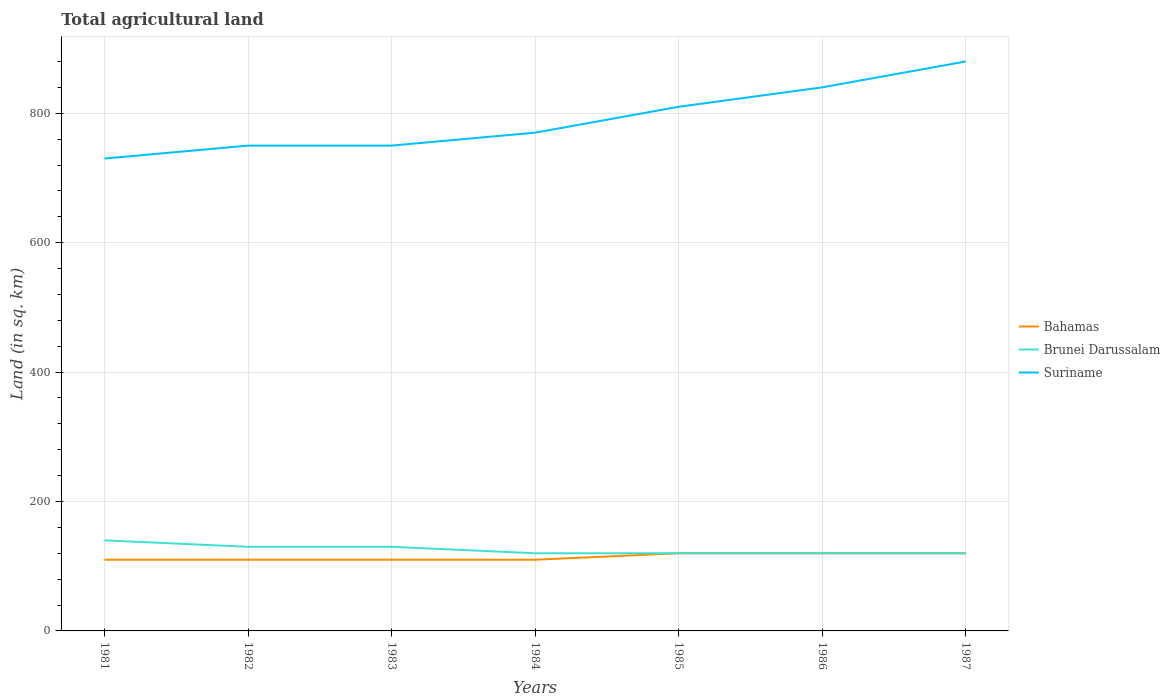Is the number of lines equal to the number of legend labels?
Ensure brevity in your answer.  Yes. Across all years, what is the maximum total agricultural land in Bahamas?
Your answer should be very brief. 110. What is the total total agricultural land in Bahamas in the graph?
Offer a very short reply. -10. What is the difference between the highest and the second highest total agricultural land in Brunei Darussalam?
Provide a succinct answer. 20. How many lines are there?
Your answer should be compact. 3. How many years are there in the graph?
Your answer should be very brief. 7. Are the values on the major ticks of Y-axis written in scientific E-notation?
Your answer should be compact. No. Does the graph contain any zero values?
Your response must be concise. No. Does the graph contain grids?
Your answer should be very brief. Yes. Where does the legend appear in the graph?
Provide a short and direct response. Center right. How many legend labels are there?
Keep it short and to the point. 3. How are the legend labels stacked?
Give a very brief answer. Vertical. What is the title of the graph?
Ensure brevity in your answer.  Total agricultural land. What is the label or title of the X-axis?
Offer a terse response. Years. What is the label or title of the Y-axis?
Offer a very short reply. Land (in sq. km). What is the Land (in sq. km) of Bahamas in 1981?
Keep it short and to the point. 110. What is the Land (in sq. km) in Brunei Darussalam in 1981?
Give a very brief answer. 140. What is the Land (in sq. km) in Suriname in 1981?
Keep it short and to the point. 730. What is the Land (in sq. km) of Bahamas in 1982?
Make the answer very short. 110. What is the Land (in sq. km) in Brunei Darussalam in 1982?
Make the answer very short. 130. What is the Land (in sq. km) of Suriname in 1982?
Your answer should be very brief. 750. What is the Land (in sq. km) of Bahamas in 1983?
Your answer should be very brief. 110. What is the Land (in sq. km) in Brunei Darussalam in 1983?
Offer a very short reply. 130. What is the Land (in sq. km) in Suriname in 1983?
Make the answer very short. 750. What is the Land (in sq. km) of Bahamas in 1984?
Your answer should be very brief. 110. What is the Land (in sq. km) of Brunei Darussalam in 1984?
Your response must be concise. 120. What is the Land (in sq. km) of Suriname in 1984?
Make the answer very short. 770. What is the Land (in sq. km) in Bahamas in 1985?
Offer a terse response. 120. What is the Land (in sq. km) in Brunei Darussalam in 1985?
Ensure brevity in your answer.  120. What is the Land (in sq. km) of Suriname in 1985?
Give a very brief answer. 810. What is the Land (in sq. km) of Bahamas in 1986?
Give a very brief answer. 120. What is the Land (in sq. km) of Brunei Darussalam in 1986?
Offer a very short reply. 120. What is the Land (in sq. km) of Suriname in 1986?
Make the answer very short. 840. What is the Land (in sq. km) in Bahamas in 1987?
Ensure brevity in your answer.  120. What is the Land (in sq. km) in Brunei Darussalam in 1987?
Your answer should be very brief. 120. What is the Land (in sq. km) in Suriname in 1987?
Your answer should be compact. 880. Across all years, what is the maximum Land (in sq. km) in Bahamas?
Offer a terse response. 120. Across all years, what is the maximum Land (in sq. km) of Brunei Darussalam?
Make the answer very short. 140. Across all years, what is the maximum Land (in sq. km) of Suriname?
Give a very brief answer. 880. Across all years, what is the minimum Land (in sq. km) in Bahamas?
Your response must be concise. 110. Across all years, what is the minimum Land (in sq. km) of Brunei Darussalam?
Your answer should be compact. 120. Across all years, what is the minimum Land (in sq. km) of Suriname?
Offer a very short reply. 730. What is the total Land (in sq. km) of Bahamas in the graph?
Keep it short and to the point. 800. What is the total Land (in sq. km) of Brunei Darussalam in the graph?
Ensure brevity in your answer.  880. What is the total Land (in sq. km) of Suriname in the graph?
Make the answer very short. 5530. What is the difference between the Land (in sq. km) in Bahamas in 1981 and that in 1982?
Give a very brief answer. 0. What is the difference between the Land (in sq. km) of Brunei Darussalam in 1981 and that in 1982?
Offer a very short reply. 10. What is the difference between the Land (in sq. km) of Bahamas in 1981 and that in 1983?
Offer a terse response. 0. What is the difference between the Land (in sq. km) of Brunei Darussalam in 1981 and that in 1983?
Your answer should be compact. 10. What is the difference between the Land (in sq. km) of Suriname in 1981 and that in 1983?
Your answer should be compact. -20. What is the difference between the Land (in sq. km) of Brunei Darussalam in 1981 and that in 1984?
Provide a succinct answer. 20. What is the difference between the Land (in sq. km) of Suriname in 1981 and that in 1984?
Provide a succinct answer. -40. What is the difference between the Land (in sq. km) in Bahamas in 1981 and that in 1985?
Make the answer very short. -10. What is the difference between the Land (in sq. km) of Suriname in 1981 and that in 1985?
Give a very brief answer. -80. What is the difference between the Land (in sq. km) in Bahamas in 1981 and that in 1986?
Provide a succinct answer. -10. What is the difference between the Land (in sq. km) of Brunei Darussalam in 1981 and that in 1986?
Your response must be concise. 20. What is the difference between the Land (in sq. km) in Suriname in 1981 and that in 1986?
Provide a short and direct response. -110. What is the difference between the Land (in sq. km) in Bahamas in 1981 and that in 1987?
Keep it short and to the point. -10. What is the difference between the Land (in sq. km) of Brunei Darussalam in 1981 and that in 1987?
Give a very brief answer. 20. What is the difference between the Land (in sq. km) in Suriname in 1981 and that in 1987?
Offer a terse response. -150. What is the difference between the Land (in sq. km) of Bahamas in 1982 and that in 1983?
Your answer should be very brief. 0. What is the difference between the Land (in sq. km) in Brunei Darussalam in 1982 and that in 1983?
Make the answer very short. 0. What is the difference between the Land (in sq. km) of Suriname in 1982 and that in 1983?
Your answer should be very brief. 0. What is the difference between the Land (in sq. km) of Suriname in 1982 and that in 1985?
Provide a succinct answer. -60. What is the difference between the Land (in sq. km) of Bahamas in 1982 and that in 1986?
Make the answer very short. -10. What is the difference between the Land (in sq. km) in Brunei Darussalam in 1982 and that in 1986?
Provide a short and direct response. 10. What is the difference between the Land (in sq. km) in Suriname in 1982 and that in 1986?
Give a very brief answer. -90. What is the difference between the Land (in sq. km) of Suriname in 1982 and that in 1987?
Provide a succinct answer. -130. What is the difference between the Land (in sq. km) of Suriname in 1983 and that in 1984?
Your answer should be compact. -20. What is the difference between the Land (in sq. km) of Bahamas in 1983 and that in 1985?
Keep it short and to the point. -10. What is the difference between the Land (in sq. km) of Suriname in 1983 and that in 1985?
Your response must be concise. -60. What is the difference between the Land (in sq. km) of Bahamas in 1983 and that in 1986?
Your response must be concise. -10. What is the difference between the Land (in sq. km) of Suriname in 1983 and that in 1986?
Offer a terse response. -90. What is the difference between the Land (in sq. km) in Bahamas in 1983 and that in 1987?
Your answer should be very brief. -10. What is the difference between the Land (in sq. km) in Brunei Darussalam in 1983 and that in 1987?
Ensure brevity in your answer.  10. What is the difference between the Land (in sq. km) in Suriname in 1983 and that in 1987?
Keep it short and to the point. -130. What is the difference between the Land (in sq. km) of Bahamas in 1984 and that in 1985?
Make the answer very short. -10. What is the difference between the Land (in sq. km) in Brunei Darussalam in 1984 and that in 1985?
Make the answer very short. 0. What is the difference between the Land (in sq. km) of Suriname in 1984 and that in 1985?
Keep it short and to the point. -40. What is the difference between the Land (in sq. km) of Brunei Darussalam in 1984 and that in 1986?
Keep it short and to the point. 0. What is the difference between the Land (in sq. km) in Suriname in 1984 and that in 1986?
Your response must be concise. -70. What is the difference between the Land (in sq. km) in Bahamas in 1984 and that in 1987?
Ensure brevity in your answer.  -10. What is the difference between the Land (in sq. km) in Suriname in 1984 and that in 1987?
Make the answer very short. -110. What is the difference between the Land (in sq. km) in Bahamas in 1985 and that in 1986?
Ensure brevity in your answer.  0. What is the difference between the Land (in sq. km) in Brunei Darussalam in 1985 and that in 1986?
Make the answer very short. 0. What is the difference between the Land (in sq. km) of Bahamas in 1985 and that in 1987?
Make the answer very short. 0. What is the difference between the Land (in sq. km) of Brunei Darussalam in 1985 and that in 1987?
Offer a very short reply. 0. What is the difference between the Land (in sq. km) of Suriname in 1985 and that in 1987?
Your response must be concise. -70. What is the difference between the Land (in sq. km) of Brunei Darussalam in 1986 and that in 1987?
Ensure brevity in your answer.  0. What is the difference between the Land (in sq. km) in Suriname in 1986 and that in 1987?
Provide a succinct answer. -40. What is the difference between the Land (in sq. km) of Bahamas in 1981 and the Land (in sq. km) of Suriname in 1982?
Your answer should be compact. -640. What is the difference between the Land (in sq. km) of Brunei Darussalam in 1981 and the Land (in sq. km) of Suriname in 1982?
Provide a short and direct response. -610. What is the difference between the Land (in sq. km) in Bahamas in 1981 and the Land (in sq. km) in Brunei Darussalam in 1983?
Keep it short and to the point. -20. What is the difference between the Land (in sq. km) in Bahamas in 1981 and the Land (in sq. km) in Suriname in 1983?
Your answer should be compact. -640. What is the difference between the Land (in sq. km) in Brunei Darussalam in 1981 and the Land (in sq. km) in Suriname in 1983?
Provide a short and direct response. -610. What is the difference between the Land (in sq. km) of Bahamas in 1981 and the Land (in sq. km) of Suriname in 1984?
Provide a succinct answer. -660. What is the difference between the Land (in sq. km) in Brunei Darussalam in 1981 and the Land (in sq. km) in Suriname in 1984?
Give a very brief answer. -630. What is the difference between the Land (in sq. km) in Bahamas in 1981 and the Land (in sq. km) in Suriname in 1985?
Offer a very short reply. -700. What is the difference between the Land (in sq. km) of Brunei Darussalam in 1981 and the Land (in sq. km) of Suriname in 1985?
Provide a short and direct response. -670. What is the difference between the Land (in sq. km) in Bahamas in 1981 and the Land (in sq. km) in Suriname in 1986?
Keep it short and to the point. -730. What is the difference between the Land (in sq. km) of Brunei Darussalam in 1981 and the Land (in sq. km) of Suriname in 1986?
Provide a short and direct response. -700. What is the difference between the Land (in sq. km) in Bahamas in 1981 and the Land (in sq. km) in Brunei Darussalam in 1987?
Provide a short and direct response. -10. What is the difference between the Land (in sq. km) of Bahamas in 1981 and the Land (in sq. km) of Suriname in 1987?
Offer a terse response. -770. What is the difference between the Land (in sq. km) in Brunei Darussalam in 1981 and the Land (in sq. km) in Suriname in 1987?
Give a very brief answer. -740. What is the difference between the Land (in sq. km) of Bahamas in 1982 and the Land (in sq. km) of Suriname in 1983?
Provide a short and direct response. -640. What is the difference between the Land (in sq. km) of Brunei Darussalam in 1982 and the Land (in sq. km) of Suriname in 1983?
Your response must be concise. -620. What is the difference between the Land (in sq. km) in Bahamas in 1982 and the Land (in sq. km) in Suriname in 1984?
Offer a very short reply. -660. What is the difference between the Land (in sq. km) in Brunei Darussalam in 1982 and the Land (in sq. km) in Suriname in 1984?
Ensure brevity in your answer.  -640. What is the difference between the Land (in sq. km) in Bahamas in 1982 and the Land (in sq. km) in Suriname in 1985?
Keep it short and to the point. -700. What is the difference between the Land (in sq. km) of Brunei Darussalam in 1982 and the Land (in sq. km) of Suriname in 1985?
Provide a short and direct response. -680. What is the difference between the Land (in sq. km) of Bahamas in 1982 and the Land (in sq. km) of Suriname in 1986?
Offer a terse response. -730. What is the difference between the Land (in sq. km) of Brunei Darussalam in 1982 and the Land (in sq. km) of Suriname in 1986?
Keep it short and to the point. -710. What is the difference between the Land (in sq. km) of Bahamas in 1982 and the Land (in sq. km) of Suriname in 1987?
Your answer should be compact. -770. What is the difference between the Land (in sq. km) in Brunei Darussalam in 1982 and the Land (in sq. km) in Suriname in 1987?
Make the answer very short. -750. What is the difference between the Land (in sq. km) of Bahamas in 1983 and the Land (in sq. km) of Suriname in 1984?
Keep it short and to the point. -660. What is the difference between the Land (in sq. km) in Brunei Darussalam in 1983 and the Land (in sq. km) in Suriname in 1984?
Ensure brevity in your answer.  -640. What is the difference between the Land (in sq. km) of Bahamas in 1983 and the Land (in sq. km) of Suriname in 1985?
Your answer should be compact. -700. What is the difference between the Land (in sq. km) in Brunei Darussalam in 1983 and the Land (in sq. km) in Suriname in 1985?
Provide a short and direct response. -680. What is the difference between the Land (in sq. km) in Bahamas in 1983 and the Land (in sq. km) in Brunei Darussalam in 1986?
Provide a short and direct response. -10. What is the difference between the Land (in sq. km) in Bahamas in 1983 and the Land (in sq. km) in Suriname in 1986?
Offer a very short reply. -730. What is the difference between the Land (in sq. km) of Brunei Darussalam in 1983 and the Land (in sq. km) of Suriname in 1986?
Provide a short and direct response. -710. What is the difference between the Land (in sq. km) of Bahamas in 1983 and the Land (in sq. km) of Brunei Darussalam in 1987?
Give a very brief answer. -10. What is the difference between the Land (in sq. km) in Bahamas in 1983 and the Land (in sq. km) in Suriname in 1987?
Keep it short and to the point. -770. What is the difference between the Land (in sq. km) of Brunei Darussalam in 1983 and the Land (in sq. km) of Suriname in 1987?
Provide a succinct answer. -750. What is the difference between the Land (in sq. km) of Bahamas in 1984 and the Land (in sq. km) of Suriname in 1985?
Provide a short and direct response. -700. What is the difference between the Land (in sq. km) of Brunei Darussalam in 1984 and the Land (in sq. km) of Suriname in 1985?
Keep it short and to the point. -690. What is the difference between the Land (in sq. km) of Bahamas in 1984 and the Land (in sq. km) of Brunei Darussalam in 1986?
Keep it short and to the point. -10. What is the difference between the Land (in sq. km) of Bahamas in 1984 and the Land (in sq. km) of Suriname in 1986?
Provide a short and direct response. -730. What is the difference between the Land (in sq. km) of Brunei Darussalam in 1984 and the Land (in sq. km) of Suriname in 1986?
Give a very brief answer. -720. What is the difference between the Land (in sq. km) in Bahamas in 1984 and the Land (in sq. km) in Brunei Darussalam in 1987?
Give a very brief answer. -10. What is the difference between the Land (in sq. km) of Bahamas in 1984 and the Land (in sq. km) of Suriname in 1987?
Your answer should be very brief. -770. What is the difference between the Land (in sq. km) of Brunei Darussalam in 1984 and the Land (in sq. km) of Suriname in 1987?
Offer a very short reply. -760. What is the difference between the Land (in sq. km) in Bahamas in 1985 and the Land (in sq. km) in Suriname in 1986?
Your answer should be compact. -720. What is the difference between the Land (in sq. km) of Brunei Darussalam in 1985 and the Land (in sq. km) of Suriname in 1986?
Make the answer very short. -720. What is the difference between the Land (in sq. km) in Bahamas in 1985 and the Land (in sq. km) in Suriname in 1987?
Your answer should be compact. -760. What is the difference between the Land (in sq. km) in Brunei Darussalam in 1985 and the Land (in sq. km) in Suriname in 1987?
Keep it short and to the point. -760. What is the difference between the Land (in sq. km) of Bahamas in 1986 and the Land (in sq. km) of Brunei Darussalam in 1987?
Offer a terse response. 0. What is the difference between the Land (in sq. km) in Bahamas in 1986 and the Land (in sq. km) in Suriname in 1987?
Provide a succinct answer. -760. What is the difference between the Land (in sq. km) in Brunei Darussalam in 1986 and the Land (in sq. km) in Suriname in 1987?
Your response must be concise. -760. What is the average Land (in sq. km) of Bahamas per year?
Give a very brief answer. 114.29. What is the average Land (in sq. km) of Brunei Darussalam per year?
Your answer should be very brief. 125.71. What is the average Land (in sq. km) of Suriname per year?
Give a very brief answer. 790. In the year 1981, what is the difference between the Land (in sq. km) in Bahamas and Land (in sq. km) in Suriname?
Your answer should be very brief. -620. In the year 1981, what is the difference between the Land (in sq. km) of Brunei Darussalam and Land (in sq. km) of Suriname?
Your response must be concise. -590. In the year 1982, what is the difference between the Land (in sq. km) of Bahamas and Land (in sq. km) of Brunei Darussalam?
Make the answer very short. -20. In the year 1982, what is the difference between the Land (in sq. km) of Bahamas and Land (in sq. km) of Suriname?
Keep it short and to the point. -640. In the year 1982, what is the difference between the Land (in sq. km) of Brunei Darussalam and Land (in sq. km) of Suriname?
Keep it short and to the point. -620. In the year 1983, what is the difference between the Land (in sq. km) of Bahamas and Land (in sq. km) of Suriname?
Ensure brevity in your answer.  -640. In the year 1983, what is the difference between the Land (in sq. km) of Brunei Darussalam and Land (in sq. km) of Suriname?
Make the answer very short. -620. In the year 1984, what is the difference between the Land (in sq. km) of Bahamas and Land (in sq. km) of Brunei Darussalam?
Provide a short and direct response. -10. In the year 1984, what is the difference between the Land (in sq. km) in Bahamas and Land (in sq. km) in Suriname?
Provide a succinct answer. -660. In the year 1984, what is the difference between the Land (in sq. km) in Brunei Darussalam and Land (in sq. km) in Suriname?
Your response must be concise. -650. In the year 1985, what is the difference between the Land (in sq. km) in Bahamas and Land (in sq. km) in Brunei Darussalam?
Offer a terse response. 0. In the year 1985, what is the difference between the Land (in sq. km) in Bahamas and Land (in sq. km) in Suriname?
Offer a terse response. -690. In the year 1985, what is the difference between the Land (in sq. km) of Brunei Darussalam and Land (in sq. km) of Suriname?
Provide a succinct answer. -690. In the year 1986, what is the difference between the Land (in sq. km) of Bahamas and Land (in sq. km) of Suriname?
Ensure brevity in your answer.  -720. In the year 1986, what is the difference between the Land (in sq. km) in Brunei Darussalam and Land (in sq. km) in Suriname?
Give a very brief answer. -720. In the year 1987, what is the difference between the Land (in sq. km) of Bahamas and Land (in sq. km) of Brunei Darussalam?
Ensure brevity in your answer.  0. In the year 1987, what is the difference between the Land (in sq. km) in Bahamas and Land (in sq. km) in Suriname?
Make the answer very short. -760. In the year 1987, what is the difference between the Land (in sq. km) of Brunei Darussalam and Land (in sq. km) of Suriname?
Provide a succinct answer. -760. What is the ratio of the Land (in sq. km) of Bahamas in 1981 to that in 1982?
Your answer should be very brief. 1. What is the ratio of the Land (in sq. km) in Suriname in 1981 to that in 1982?
Your answer should be compact. 0.97. What is the ratio of the Land (in sq. km) of Bahamas in 1981 to that in 1983?
Your answer should be compact. 1. What is the ratio of the Land (in sq. km) of Brunei Darussalam in 1981 to that in 1983?
Provide a short and direct response. 1.08. What is the ratio of the Land (in sq. km) of Suriname in 1981 to that in 1983?
Keep it short and to the point. 0.97. What is the ratio of the Land (in sq. km) of Brunei Darussalam in 1981 to that in 1984?
Your answer should be very brief. 1.17. What is the ratio of the Land (in sq. km) in Suriname in 1981 to that in 1984?
Offer a very short reply. 0.95. What is the ratio of the Land (in sq. km) in Bahamas in 1981 to that in 1985?
Provide a short and direct response. 0.92. What is the ratio of the Land (in sq. km) of Suriname in 1981 to that in 1985?
Ensure brevity in your answer.  0.9. What is the ratio of the Land (in sq. km) in Brunei Darussalam in 1981 to that in 1986?
Provide a short and direct response. 1.17. What is the ratio of the Land (in sq. km) in Suriname in 1981 to that in 1986?
Ensure brevity in your answer.  0.87. What is the ratio of the Land (in sq. km) in Brunei Darussalam in 1981 to that in 1987?
Provide a succinct answer. 1.17. What is the ratio of the Land (in sq. km) of Suriname in 1981 to that in 1987?
Your answer should be very brief. 0.83. What is the ratio of the Land (in sq. km) of Bahamas in 1982 to that in 1983?
Make the answer very short. 1. What is the ratio of the Land (in sq. km) in Suriname in 1982 to that in 1983?
Keep it short and to the point. 1. What is the ratio of the Land (in sq. km) in Suriname in 1982 to that in 1985?
Your response must be concise. 0.93. What is the ratio of the Land (in sq. km) in Bahamas in 1982 to that in 1986?
Offer a terse response. 0.92. What is the ratio of the Land (in sq. km) in Brunei Darussalam in 1982 to that in 1986?
Give a very brief answer. 1.08. What is the ratio of the Land (in sq. km) in Suriname in 1982 to that in 1986?
Provide a short and direct response. 0.89. What is the ratio of the Land (in sq. km) of Bahamas in 1982 to that in 1987?
Provide a short and direct response. 0.92. What is the ratio of the Land (in sq. km) of Brunei Darussalam in 1982 to that in 1987?
Offer a very short reply. 1.08. What is the ratio of the Land (in sq. km) of Suriname in 1982 to that in 1987?
Keep it short and to the point. 0.85. What is the ratio of the Land (in sq. km) in Bahamas in 1983 to that in 1984?
Provide a succinct answer. 1. What is the ratio of the Land (in sq. km) in Suriname in 1983 to that in 1984?
Your answer should be compact. 0.97. What is the ratio of the Land (in sq. km) of Bahamas in 1983 to that in 1985?
Your answer should be compact. 0.92. What is the ratio of the Land (in sq. km) in Suriname in 1983 to that in 1985?
Offer a terse response. 0.93. What is the ratio of the Land (in sq. km) of Bahamas in 1983 to that in 1986?
Keep it short and to the point. 0.92. What is the ratio of the Land (in sq. km) of Brunei Darussalam in 1983 to that in 1986?
Your answer should be compact. 1.08. What is the ratio of the Land (in sq. km) of Suriname in 1983 to that in 1986?
Your response must be concise. 0.89. What is the ratio of the Land (in sq. km) of Bahamas in 1983 to that in 1987?
Offer a terse response. 0.92. What is the ratio of the Land (in sq. km) of Brunei Darussalam in 1983 to that in 1987?
Offer a terse response. 1.08. What is the ratio of the Land (in sq. km) in Suriname in 1983 to that in 1987?
Your answer should be compact. 0.85. What is the ratio of the Land (in sq. km) of Bahamas in 1984 to that in 1985?
Provide a succinct answer. 0.92. What is the ratio of the Land (in sq. km) of Suriname in 1984 to that in 1985?
Ensure brevity in your answer.  0.95. What is the ratio of the Land (in sq. km) in Suriname in 1984 to that in 1986?
Ensure brevity in your answer.  0.92. What is the ratio of the Land (in sq. km) of Bahamas in 1984 to that in 1987?
Your response must be concise. 0.92. What is the ratio of the Land (in sq. km) of Bahamas in 1985 to that in 1986?
Ensure brevity in your answer.  1. What is the ratio of the Land (in sq. km) in Brunei Darussalam in 1985 to that in 1986?
Make the answer very short. 1. What is the ratio of the Land (in sq. km) in Brunei Darussalam in 1985 to that in 1987?
Make the answer very short. 1. What is the ratio of the Land (in sq. km) of Suriname in 1985 to that in 1987?
Your answer should be compact. 0.92. What is the ratio of the Land (in sq. km) in Suriname in 1986 to that in 1987?
Offer a terse response. 0.95. What is the difference between the highest and the second highest Land (in sq. km) of Bahamas?
Your response must be concise. 0. What is the difference between the highest and the second highest Land (in sq. km) in Brunei Darussalam?
Offer a very short reply. 10. What is the difference between the highest and the lowest Land (in sq. km) of Bahamas?
Give a very brief answer. 10. What is the difference between the highest and the lowest Land (in sq. km) in Suriname?
Your answer should be compact. 150. 